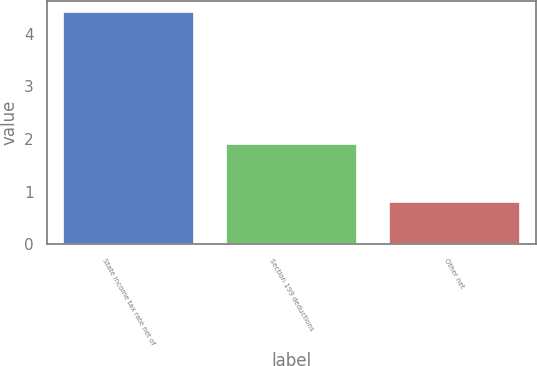Convert chart. <chart><loc_0><loc_0><loc_500><loc_500><bar_chart><fcel>State income tax rate net of<fcel>Section 199 deductions<fcel>Other net<nl><fcel>4.4<fcel>1.9<fcel>0.8<nl></chart> 